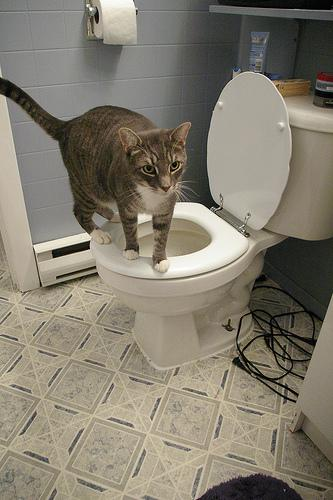Question: what is the cat standing on?
Choices:
A. The computer keyboard.
B. The window sill.
C. A pillow.
D. The toilet.
Answer with the letter. Answer: D Question: who is on the toilet?
Choices:
A. The man.
B. A cat.
C. The woman.
D. The child.
Answer with the letter. Answer: B Question: where was the photo taken?
Choices:
A. The park.
B. The lake.
C. Bathroom.
D. The party.
Answer with the letter. Answer: C Question: how many cats in the bathroom?
Choices:
A. Two.
B. One.
C. Three.
D. None.
Answer with the letter. Answer: B 